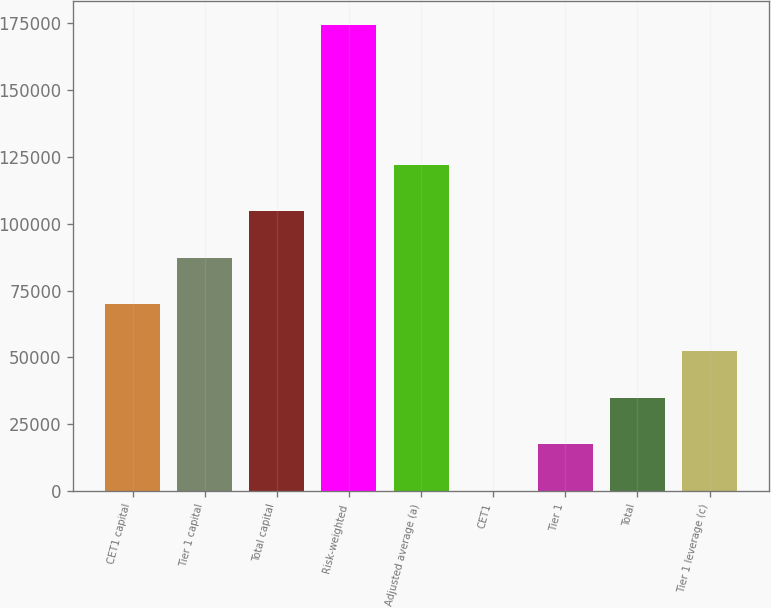Convert chart to OTSL. <chart><loc_0><loc_0><loc_500><loc_500><bar_chart><fcel>CET1 capital<fcel>Tier 1 capital<fcel>Total capital<fcel>Risk-weighted<fcel>Adjusted average (a)<fcel>CET1<fcel>Tier 1<fcel>Total<fcel>Tier 1 leverage (c)<nl><fcel>69795.8<fcel>87241.3<fcel>104687<fcel>174469<fcel>122132<fcel>13.6<fcel>17459.1<fcel>34904.7<fcel>52350.2<nl></chart> 